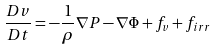<formula> <loc_0><loc_0><loc_500><loc_500>\frac { D v } { D t } = - \frac { 1 } { \rho } \nabla P - \nabla \Phi + f _ { v } + f _ { i r r }</formula> 